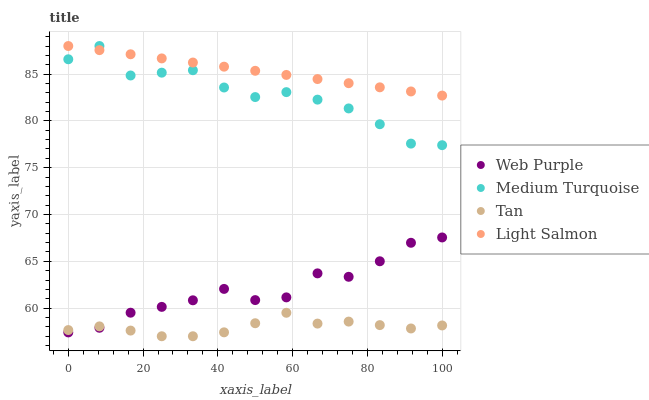Does Tan have the minimum area under the curve?
Answer yes or no. Yes. Does Light Salmon have the maximum area under the curve?
Answer yes or no. Yes. Does Medium Turquoise have the minimum area under the curve?
Answer yes or no. No. Does Medium Turquoise have the maximum area under the curve?
Answer yes or no. No. Is Light Salmon the smoothest?
Answer yes or no. Yes. Is Medium Turquoise the roughest?
Answer yes or no. Yes. Is Tan the smoothest?
Answer yes or no. No. Is Tan the roughest?
Answer yes or no. No. Does Tan have the lowest value?
Answer yes or no. Yes. Does Medium Turquoise have the lowest value?
Answer yes or no. No. Does Light Salmon have the highest value?
Answer yes or no. Yes. Does Tan have the highest value?
Answer yes or no. No. Is Tan less than Light Salmon?
Answer yes or no. Yes. Is Light Salmon greater than Web Purple?
Answer yes or no. Yes. Does Web Purple intersect Tan?
Answer yes or no. Yes. Is Web Purple less than Tan?
Answer yes or no. No. Is Web Purple greater than Tan?
Answer yes or no. No. Does Tan intersect Light Salmon?
Answer yes or no. No. 